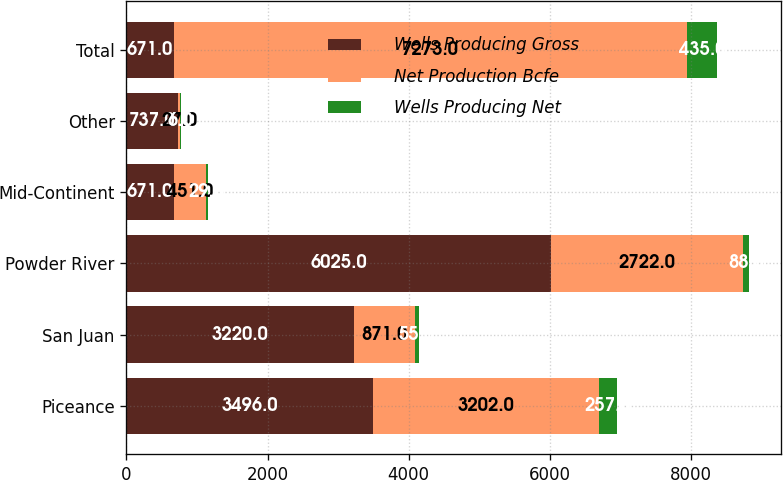Convert chart. <chart><loc_0><loc_0><loc_500><loc_500><stacked_bar_chart><ecel><fcel>Piceance<fcel>San Juan<fcel>Powder River<fcel>Mid-Continent<fcel>Other<fcel>Total<nl><fcel>Wells Producing Gross<fcel>3496<fcel>3220<fcel>6025<fcel>671<fcel>737<fcel>671<nl><fcel>Net Production Bcfe<fcel>3202<fcel>871<fcel>2722<fcel>451<fcel>27<fcel>7273<nl><fcel>Wells Producing Net<fcel>257<fcel>55<fcel>88<fcel>29<fcel>6<fcel>435<nl></chart> 